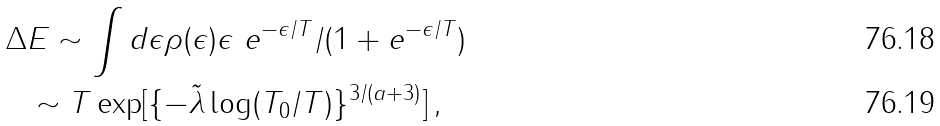<formula> <loc_0><loc_0><loc_500><loc_500>\Delta & E \sim \int d \epsilon \rho ( \epsilon ) \epsilon \ e ^ { - \epsilon / T } / ( 1 + e ^ { - \epsilon / T } ) \\ & \sim T \exp [ \{ - \tilde { \lambda } \log ( T _ { 0 } / T ) \} ^ { 3 / ( a + 3 ) } ] \, ,</formula> 